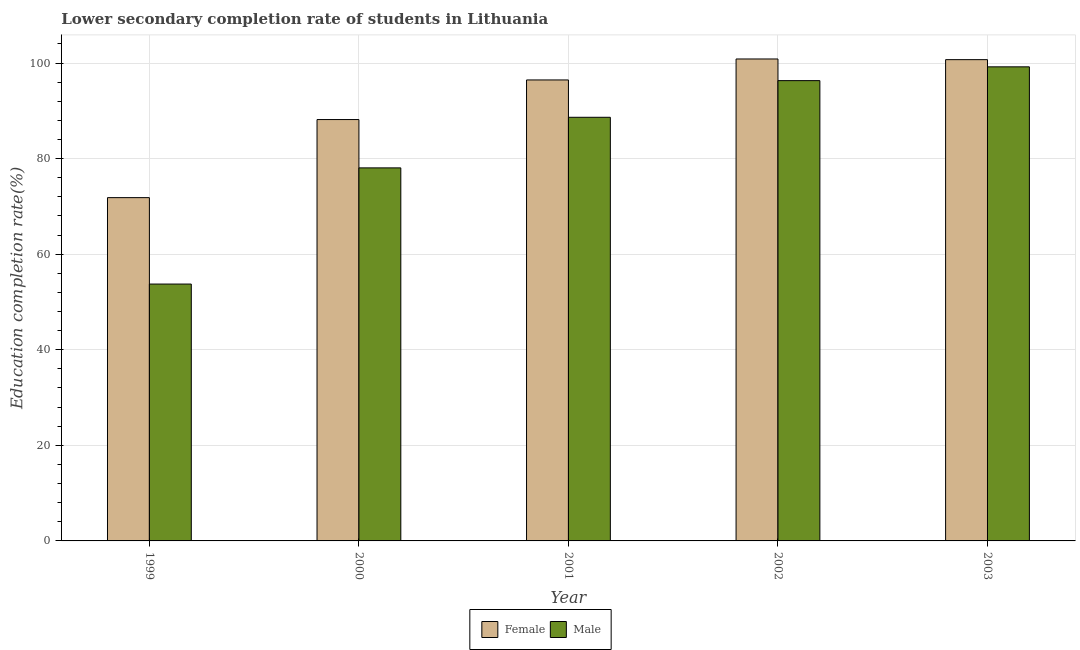Are the number of bars per tick equal to the number of legend labels?
Offer a terse response. Yes. How many bars are there on the 4th tick from the left?
Your response must be concise. 2. How many bars are there on the 3rd tick from the right?
Provide a short and direct response. 2. In how many cases, is the number of bars for a given year not equal to the number of legend labels?
Offer a very short reply. 0. What is the education completion rate of female students in 2003?
Offer a terse response. 100.71. Across all years, what is the maximum education completion rate of female students?
Give a very brief answer. 100.85. Across all years, what is the minimum education completion rate of female students?
Offer a terse response. 71.83. In which year was the education completion rate of male students maximum?
Give a very brief answer. 2003. In which year was the education completion rate of male students minimum?
Your answer should be very brief. 1999. What is the total education completion rate of female students in the graph?
Ensure brevity in your answer.  458.02. What is the difference between the education completion rate of female students in 1999 and that in 2003?
Ensure brevity in your answer.  -28.87. What is the difference between the education completion rate of female students in 2001 and the education completion rate of male students in 2003?
Offer a very short reply. -4.25. What is the average education completion rate of male students per year?
Give a very brief answer. 83.19. In how many years, is the education completion rate of male students greater than 80 %?
Offer a terse response. 3. What is the ratio of the education completion rate of male students in 2001 to that in 2003?
Keep it short and to the point. 0.89. Is the difference between the education completion rate of male students in 2001 and 2003 greater than the difference between the education completion rate of female students in 2001 and 2003?
Offer a very short reply. No. What is the difference between the highest and the second highest education completion rate of male students?
Provide a succinct answer. 2.89. What is the difference between the highest and the lowest education completion rate of male students?
Provide a short and direct response. 45.45. In how many years, is the education completion rate of female students greater than the average education completion rate of female students taken over all years?
Provide a succinct answer. 3. Is the sum of the education completion rate of male students in 2000 and 2003 greater than the maximum education completion rate of female students across all years?
Give a very brief answer. Yes. How many bars are there?
Make the answer very short. 10. Are all the bars in the graph horizontal?
Your response must be concise. No. How many years are there in the graph?
Your answer should be very brief. 5. Are the values on the major ticks of Y-axis written in scientific E-notation?
Make the answer very short. No. Where does the legend appear in the graph?
Your answer should be compact. Bottom center. How many legend labels are there?
Provide a succinct answer. 2. How are the legend labels stacked?
Provide a short and direct response. Horizontal. What is the title of the graph?
Your answer should be compact. Lower secondary completion rate of students in Lithuania. What is the label or title of the X-axis?
Offer a terse response. Year. What is the label or title of the Y-axis?
Your answer should be compact. Education completion rate(%). What is the Education completion rate(%) of Female in 1999?
Give a very brief answer. 71.83. What is the Education completion rate(%) of Male in 1999?
Your answer should be very brief. 53.75. What is the Education completion rate(%) of Female in 2000?
Offer a terse response. 88.17. What is the Education completion rate(%) of Male in 2000?
Your response must be concise. 78.06. What is the Education completion rate(%) of Female in 2001?
Ensure brevity in your answer.  96.46. What is the Education completion rate(%) in Male in 2001?
Your answer should be very brief. 88.64. What is the Education completion rate(%) of Female in 2002?
Your answer should be very brief. 100.85. What is the Education completion rate(%) in Male in 2002?
Offer a terse response. 96.32. What is the Education completion rate(%) of Female in 2003?
Keep it short and to the point. 100.71. What is the Education completion rate(%) in Male in 2003?
Keep it short and to the point. 99.2. Across all years, what is the maximum Education completion rate(%) in Female?
Ensure brevity in your answer.  100.85. Across all years, what is the maximum Education completion rate(%) of Male?
Your answer should be compact. 99.2. Across all years, what is the minimum Education completion rate(%) of Female?
Your answer should be very brief. 71.83. Across all years, what is the minimum Education completion rate(%) in Male?
Provide a succinct answer. 53.75. What is the total Education completion rate(%) of Female in the graph?
Your answer should be compact. 458.02. What is the total Education completion rate(%) of Male in the graph?
Offer a very short reply. 415.97. What is the difference between the Education completion rate(%) in Female in 1999 and that in 2000?
Ensure brevity in your answer.  -16.34. What is the difference between the Education completion rate(%) of Male in 1999 and that in 2000?
Make the answer very short. -24.31. What is the difference between the Education completion rate(%) in Female in 1999 and that in 2001?
Make the answer very short. -24.63. What is the difference between the Education completion rate(%) in Male in 1999 and that in 2001?
Offer a terse response. -34.9. What is the difference between the Education completion rate(%) of Female in 1999 and that in 2002?
Offer a very short reply. -29.01. What is the difference between the Education completion rate(%) of Male in 1999 and that in 2002?
Give a very brief answer. -42.57. What is the difference between the Education completion rate(%) of Female in 1999 and that in 2003?
Offer a very short reply. -28.87. What is the difference between the Education completion rate(%) of Male in 1999 and that in 2003?
Your answer should be very brief. -45.45. What is the difference between the Education completion rate(%) in Female in 2000 and that in 2001?
Your answer should be very brief. -8.29. What is the difference between the Education completion rate(%) in Male in 2000 and that in 2001?
Offer a terse response. -10.59. What is the difference between the Education completion rate(%) of Female in 2000 and that in 2002?
Your response must be concise. -12.68. What is the difference between the Education completion rate(%) of Male in 2000 and that in 2002?
Offer a terse response. -18.26. What is the difference between the Education completion rate(%) of Female in 2000 and that in 2003?
Offer a terse response. -12.54. What is the difference between the Education completion rate(%) of Male in 2000 and that in 2003?
Offer a very short reply. -21.14. What is the difference between the Education completion rate(%) of Female in 2001 and that in 2002?
Your answer should be compact. -4.39. What is the difference between the Education completion rate(%) in Male in 2001 and that in 2002?
Offer a very short reply. -7.67. What is the difference between the Education completion rate(%) of Female in 2001 and that in 2003?
Ensure brevity in your answer.  -4.25. What is the difference between the Education completion rate(%) in Male in 2001 and that in 2003?
Keep it short and to the point. -10.56. What is the difference between the Education completion rate(%) of Female in 2002 and that in 2003?
Give a very brief answer. 0.14. What is the difference between the Education completion rate(%) in Male in 2002 and that in 2003?
Your answer should be very brief. -2.89. What is the difference between the Education completion rate(%) in Female in 1999 and the Education completion rate(%) in Male in 2000?
Make the answer very short. -6.23. What is the difference between the Education completion rate(%) in Female in 1999 and the Education completion rate(%) in Male in 2001?
Your answer should be very brief. -16.81. What is the difference between the Education completion rate(%) in Female in 1999 and the Education completion rate(%) in Male in 2002?
Provide a succinct answer. -24.48. What is the difference between the Education completion rate(%) in Female in 1999 and the Education completion rate(%) in Male in 2003?
Provide a short and direct response. -27.37. What is the difference between the Education completion rate(%) of Female in 2000 and the Education completion rate(%) of Male in 2001?
Give a very brief answer. -0.47. What is the difference between the Education completion rate(%) in Female in 2000 and the Education completion rate(%) in Male in 2002?
Give a very brief answer. -8.14. What is the difference between the Education completion rate(%) in Female in 2000 and the Education completion rate(%) in Male in 2003?
Your answer should be compact. -11.03. What is the difference between the Education completion rate(%) of Female in 2001 and the Education completion rate(%) of Male in 2002?
Offer a very short reply. 0.14. What is the difference between the Education completion rate(%) of Female in 2001 and the Education completion rate(%) of Male in 2003?
Offer a very short reply. -2.74. What is the difference between the Education completion rate(%) in Female in 2002 and the Education completion rate(%) in Male in 2003?
Ensure brevity in your answer.  1.65. What is the average Education completion rate(%) in Female per year?
Provide a succinct answer. 91.6. What is the average Education completion rate(%) of Male per year?
Your response must be concise. 83.19. In the year 1999, what is the difference between the Education completion rate(%) in Female and Education completion rate(%) in Male?
Your answer should be very brief. 18.09. In the year 2000, what is the difference between the Education completion rate(%) in Female and Education completion rate(%) in Male?
Keep it short and to the point. 10.11. In the year 2001, what is the difference between the Education completion rate(%) of Female and Education completion rate(%) of Male?
Your response must be concise. 7.81. In the year 2002, what is the difference between the Education completion rate(%) of Female and Education completion rate(%) of Male?
Keep it short and to the point. 4.53. In the year 2003, what is the difference between the Education completion rate(%) in Female and Education completion rate(%) in Male?
Make the answer very short. 1.51. What is the ratio of the Education completion rate(%) of Female in 1999 to that in 2000?
Provide a short and direct response. 0.81. What is the ratio of the Education completion rate(%) of Male in 1999 to that in 2000?
Your response must be concise. 0.69. What is the ratio of the Education completion rate(%) of Female in 1999 to that in 2001?
Provide a succinct answer. 0.74. What is the ratio of the Education completion rate(%) of Male in 1999 to that in 2001?
Provide a succinct answer. 0.61. What is the ratio of the Education completion rate(%) in Female in 1999 to that in 2002?
Give a very brief answer. 0.71. What is the ratio of the Education completion rate(%) of Male in 1999 to that in 2002?
Offer a terse response. 0.56. What is the ratio of the Education completion rate(%) of Female in 1999 to that in 2003?
Offer a very short reply. 0.71. What is the ratio of the Education completion rate(%) of Male in 1999 to that in 2003?
Ensure brevity in your answer.  0.54. What is the ratio of the Education completion rate(%) of Female in 2000 to that in 2001?
Keep it short and to the point. 0.91. What is the ratio of the Education completion rate(%) of Male in 2000 to that in 2001?
Offer a terse response. 0.88. What is the ratio of the Education completion rate(%) in Female in 2000 to that in 2002?
Offer a terse response. 0.87. What is the ratio of the Education completion rate(%) in Male in 2000 to that in 2002?
Ensure brevity in your answer.  0.81. What is the ratio of the Education completion rate(%) in Female in 2000 to that in 2003?
Offer a very short reply. 0.88. What is the ratio of the Education completion rate(%) of Male in 2000 to that in 2003?
Offer a very short reply. 0.79. What is the ratio of the Education completion rate(%) of Female in 2001 to that in 2002?
Offer a terse response. 0.96. What is the ratio of the Education completion rate(%) of Male in 2001 to that in 2002?
Offer a very short reply. 0.92. What is the ratio of the Education completion rate(%) of Female in 2001 to that in 2003?
Offer a terse response. 0.96. What is the ratio of the Education completion rate(%) of Male in 2001 to that in 2003?
Keep it short and to the point. 0.89. What is the ratio of the Education completion rate(%) in Female in 2002 to that in 2003?
Make the answer very short. 1. What is the ratio of the Education completion rate(%) in Male in 2002 to that in 2003?
Ensure brevity in your answer.  0.97. What is the difference between the highest and the second highest Education completion rate(%) of Female?
Provide a short and direct response. 0.14. What is the difference between the highest and the second highest Education completion rate(%) in Male?
Offer a very short reply. 2.89. What is the difference between the highest and the lowest Education completion rate(%) in Female?
Offer a terse response. 29.01. What is the difference between the highest and the lowest Education completion rate(%) in Male?
Make the answer very short. 45.45. 